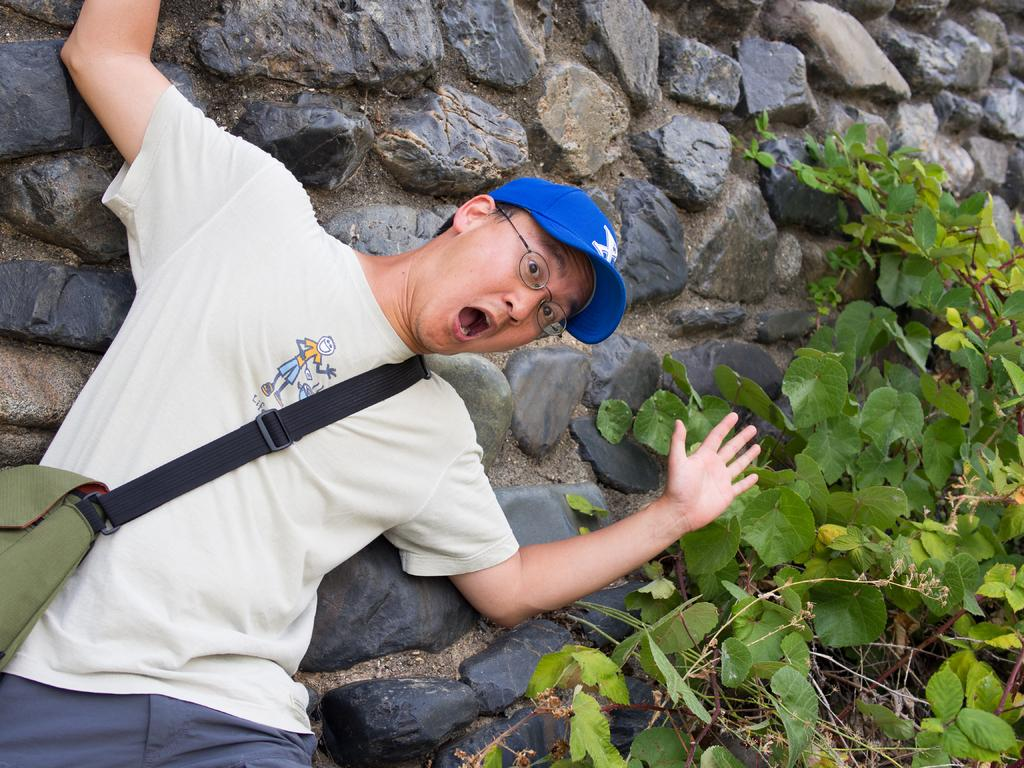What type of structure can be seen in the background of the image? There is a stone wall in the background of the image. What living organism is present in the image? There is a plant in the image. What is the man in the image wearing on his head? The man is wearing a blue cap. What type of eyewear is the man wearing in the image? The man is wearing spectacles. What type of clothing is the man wearing on his upper body? The man is wearing a t-shirt. What is the man carrying in the image? The man is carrying a bag. What is the man doing in the image? The man is giving a pose. Reasoning: Let's think step by step by breaking down the facts into individual elements and creating questions that focus on each element. We start by identifying the main subjects and objects in the image, such as the stone wall, plant, and man. Then, we describe the man's appearance and actions, including his clothing, accessories, and pose. Each question is designed to elicit a specific detail about the image that is known from the provided facts. Absurd Question/Answer: How many bikes are parked next to the stone wall in the image? There are no bikes present in the image; only a stone wall, a plant, and a man can be seen. What time of day is it in the image, and what color is the gold object being held by the man? The time of day is not mentioned in the image, and there is no gold object being held by the man. 